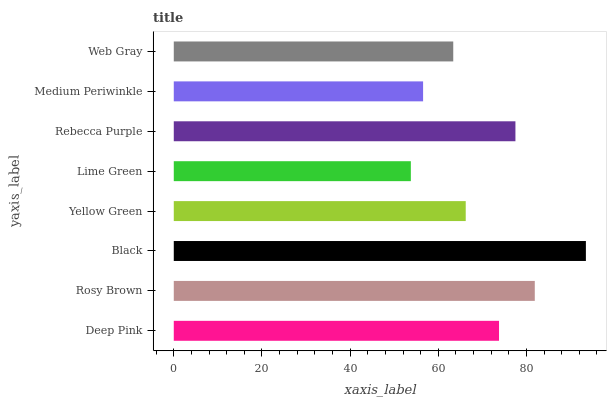Is Lime Green the minimum?
Answer yes or no. Yes. Is Black the maximum?
Answer yes or no. Yes. Is Rosy Brown the minimum?
Answer yes or no. No. Is Rosy Brown the maximum?
Answer yes or no. No. Is Rosy Brown greater than Deep Pink?
Answer yes or no. Yes. Is Deep Pink less than Rosy Brown?
Answer yes or no. Yes. Is Deep Pink greater than Rosy Brown?
Answer yes or no. No. Is Rosy Brown less than Deep Pink?
Answer yes or no. No. Is Deep Pink the high median?
Answer yes or no. Yes. Is Yellow Green the low median?
Answer yes or no. Yes. Is Rosy Brown the high median?
Answer yes or no. No. Is Rosy Brown the low median?
Answer yes or no. No. 